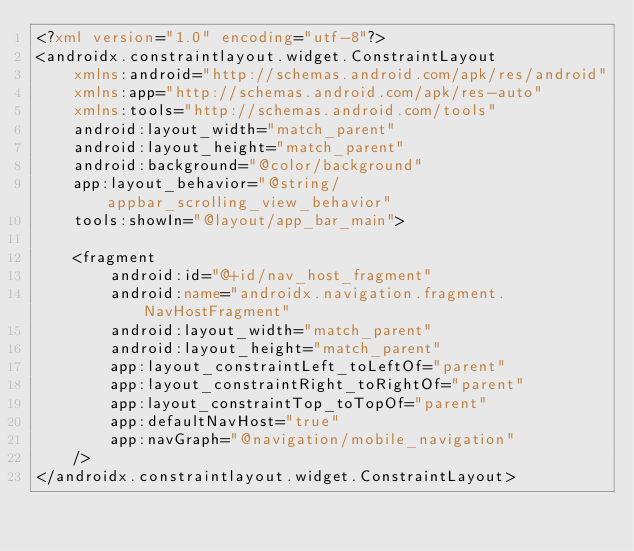Convert code to text. <code><loc_0><loc_0><loc_500><loc_500><_XML_><?xml version="1.0" encoding="utf-8"?>
<androidx.constraintlayout.widget.ConstraintLayout
    xmlns:android="http://schemas.android.com/apk/res/android"
    xmlns:app="http://schemas.android.com/apk/res-auto"
    xmlns:tools="http://schemas.android.com/tools"
    android:layout_width="match_parent"
    android:layout_height="match_parent"
    android:background="@color/background"
    app:layout_behavior="@string/appbar_scrolling_view_behavior"
    tools:showIn="@layout/app_bar_main">

    <fragment
        android:id="@+id/nav_host_fragment"
        android:name="androidx.navigation.fragment.NavHostFragment"
        android:layout_width="match_parent"
        android:layout_height="match_parent"
        app:layout_constraintLeft_toLeftOf="parent"
        app:layout_constraintRight_toRightOf="parent"
        app:layout_constraintTop_toTopOf="parent"
        app:defaultNavHost="true"
        app:navGraph="@navigation/mobile_navigation"
    />
</androidx.constraintlayout.widget.ConstraintLayout></code> 